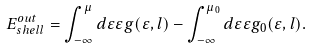Convert formula to latex. <formula><loc_0><loc_0><loc_500><loc_500>E _ { s h e l l } ^ { o u t } = \int _ { - \infty } ^ { \mu } d \varepsilon \varepsilon g ( \varepsilon , { l } ) - \int _ { - \infty } ^ { \mu _ { 0 } } d \varepsilon \varepsilon g _ { 0 } ( \varepsilon , { l } ) .</formula> 